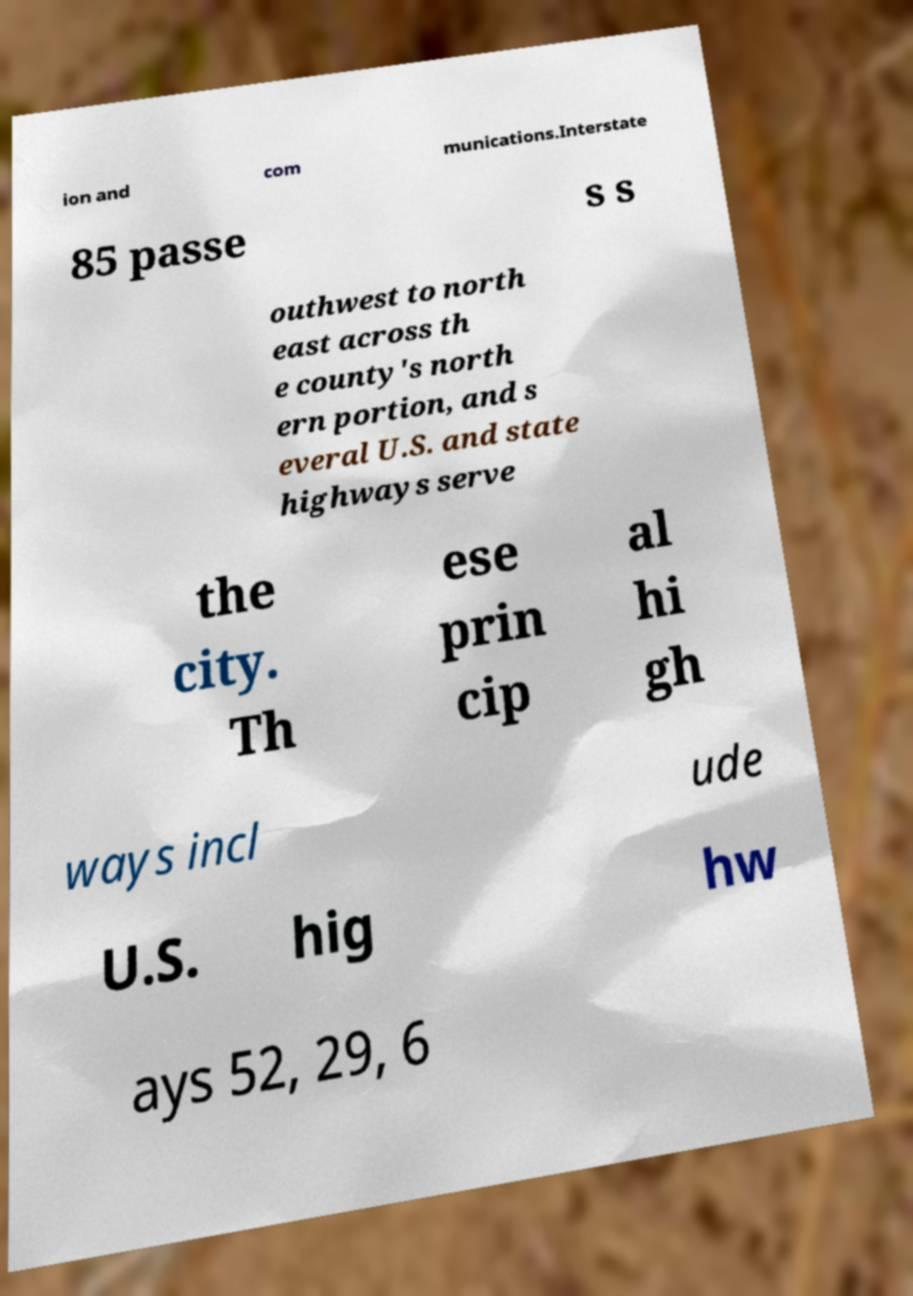What messages or text are displayed in this image? I need them in a readable, typed format. ion and com munications.Interstate 85 passe s s outhwest to north east across th e county's north ern portion, and s everal U.S. and state highways serve the city. Th ese prin cip al hi gh ways incl ude U.S. hig hw ays 52, 29, 6 